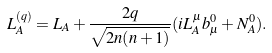Convert formula to latex. <formula><loc_0><loc_0><loc_500><loc_500>L _ { A } ^ { ( q ) } = L _ { A } + \frac { 2 q } { \sqrt { 2 n ( n + 1 ) } } ( i L _ { A } ^ { \mu } b _ { \mu } ^ { 0 } + N _ { A } ^ { 0 } ) .</formula> 